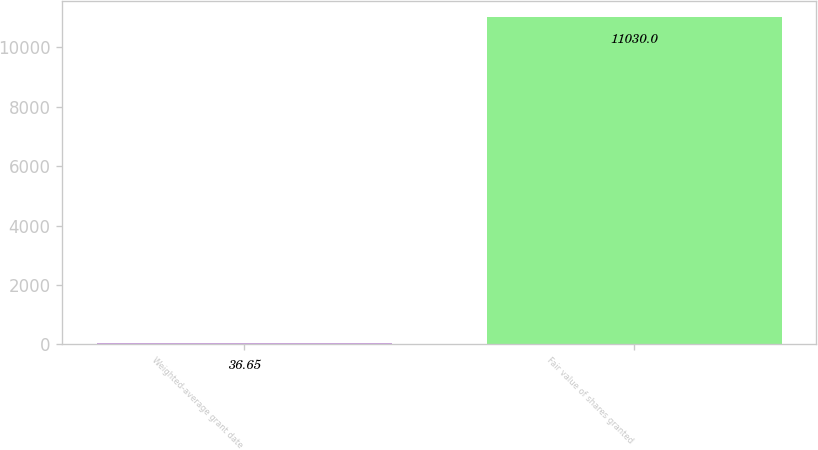Convert chart to OTSL. <chart><loc_0><loc_0><loc_500><loc_500><bar_chart><fcel>Weighted-average grant date<fcel>Fair value of shares granted<nl><fcel>36.65<fcel>11030<nl></chart> 